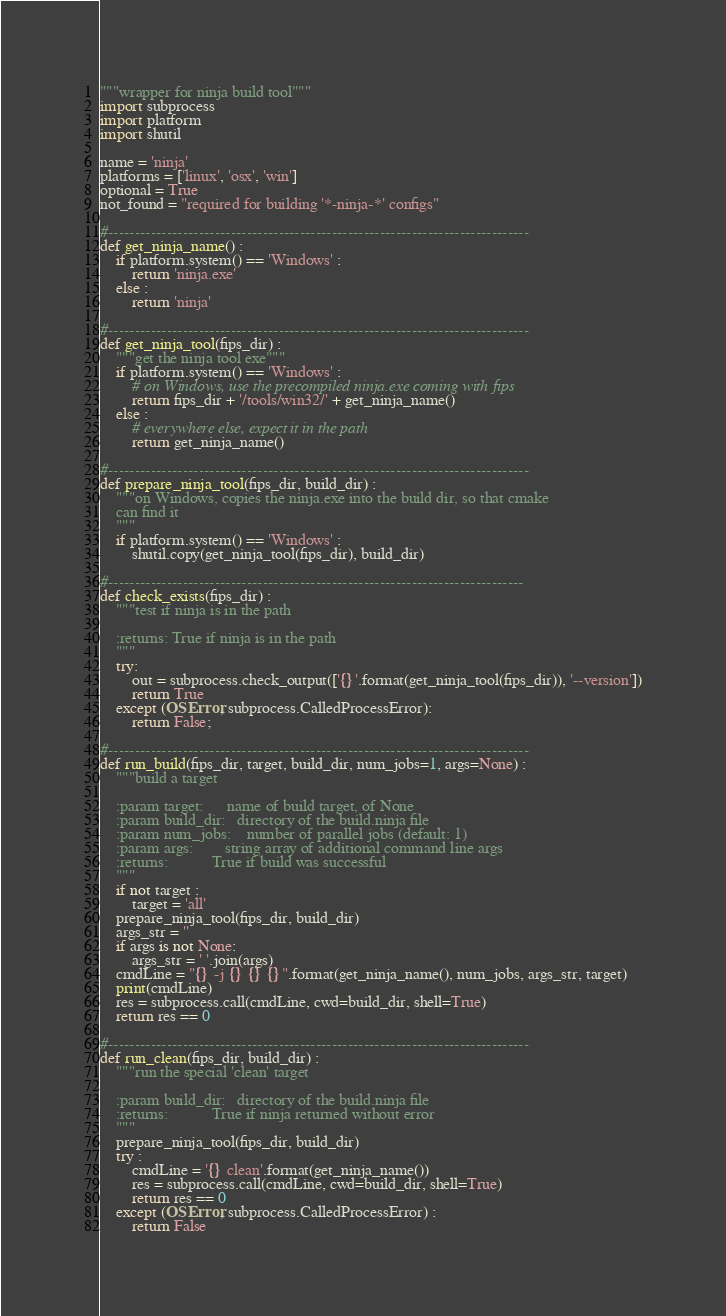Convert code to text. <code><loc_0><loc_0><loc_500><loc_500><_Python_>"""wrapper for ninja build tool"""
import subprocess
import platform
import shutil

name = 'ninja'
platforms = ['linux', 'osx', 'win']
optional = True
not_found = "required for building '*-ninja-*' configs"

#-------------------------------------------------------------------------------
def get_ninja_name() :
    if platform.system() == 'Windows' :
        return 'ninja.exe'
    else :
        return 'ninja'

#-------------------------------------------------------------------------------
def get_ninja_tool(fips_dir) :
    """get the ninja tool exe"""
    if platform.system() == 'Windows' :
        # on Windows, use the precompiled ninja.exe coming with fips
        return fips_dir + '/tools/win32/' + get_ninja_name()
    else :
        # everywhere else, expect it in the path
        return get_ninja_name()

#-------------------------------------------------------------------------------
def prepare_ninja_tool(fips_dir, build_dir) :
    """on Windows, copies the ninja.exe into the build dir, so that cmake 
    can find it
    """
    if platform.system() == 'Windows' :
        shutil.copy(get_ninja_tool(fips_dir), build_dir)

#------------------------------------------------------------------------------
def check_exists(fips_dir) :
    """test if ninja is in the path
    
    :returns: True if ninja is in the path
    """
    try:
        out = subprocess.check_output(['{}'.format(get_ninja_tool(fips_dir)), '--version'])
        return True
    except (OSError, subprocess.CalledProcessError):
        return False;

#-------------------------------------------------------------------------------
def run_build(fips_dir, target, build_dir, num_jobs=1, args=None) :
    """build a target

    :param target:      name of build target, of None
    :param build_dir:   directory of the build.ninja file
    :param num_jobs:    number of parallel jobs (default: 1)
    :param args:        string array of additional command line args
    :returns:           True if build was successful
    """
    if not target :
        target = 'all'
    prepare_ninja_tool(fips_dir, build_dir)
    args_str = ''
    if args is not None:
        args_str = ' '.join(args)
    cmdLine = "{} -j {} {} {}".format(get_ninja_name(), num_jobs, args_str, target)
    print(cmdLine)
    res = subprocess.call(cmdLine, cwd=build_dir, shell=True)
    return res == 0

#-------------------------------------------------------------------------------
def run_clean(fips_dir, build_dir) :
    """run the special 'clean' target

    :param build_dir:   directory of the build.ninja file
    :returns:           True if ninja returned without error
    """
    prepare_ninja_tool(fips_dir, build_dir)
    try :
        cmdLine = '{} clean'.format(get_ninja_name())
        res = subprocess.call(cmdLine, cwd=build_dir, shell=True)
        return res == 0
    except (OSError, subprocess.CalledProcessError) :
        return False


</code> 